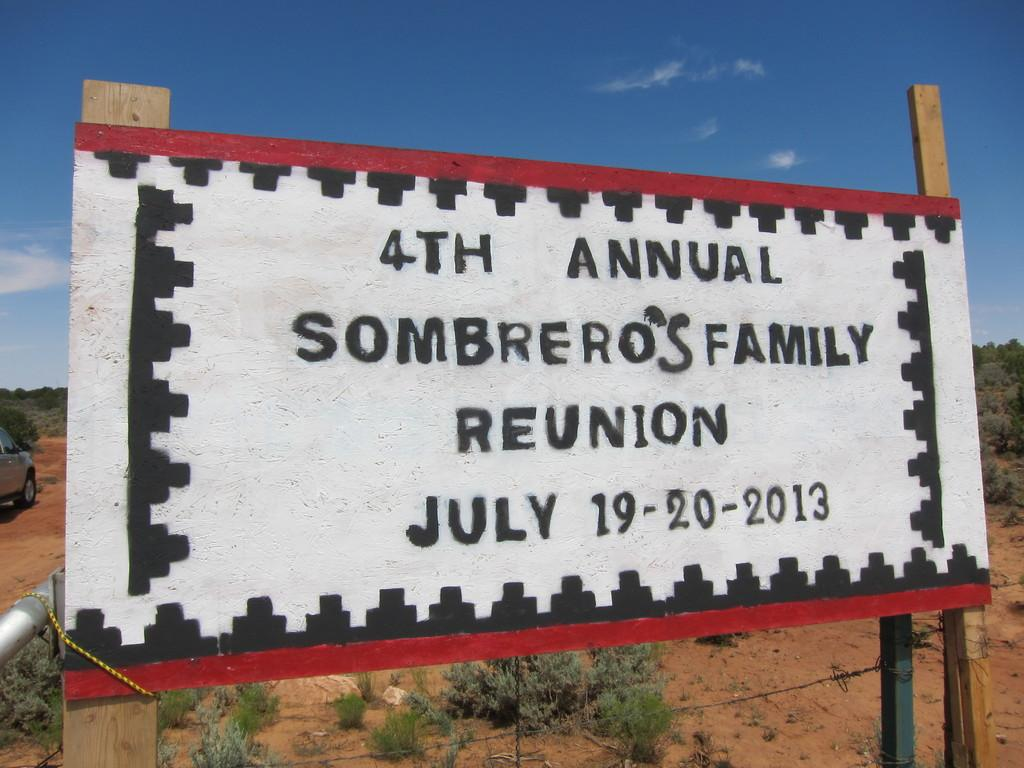<image>
Render a clear and concise summary of the photo. A white sign in the desert says 4th Annual Sombrero's Family Reunion. 